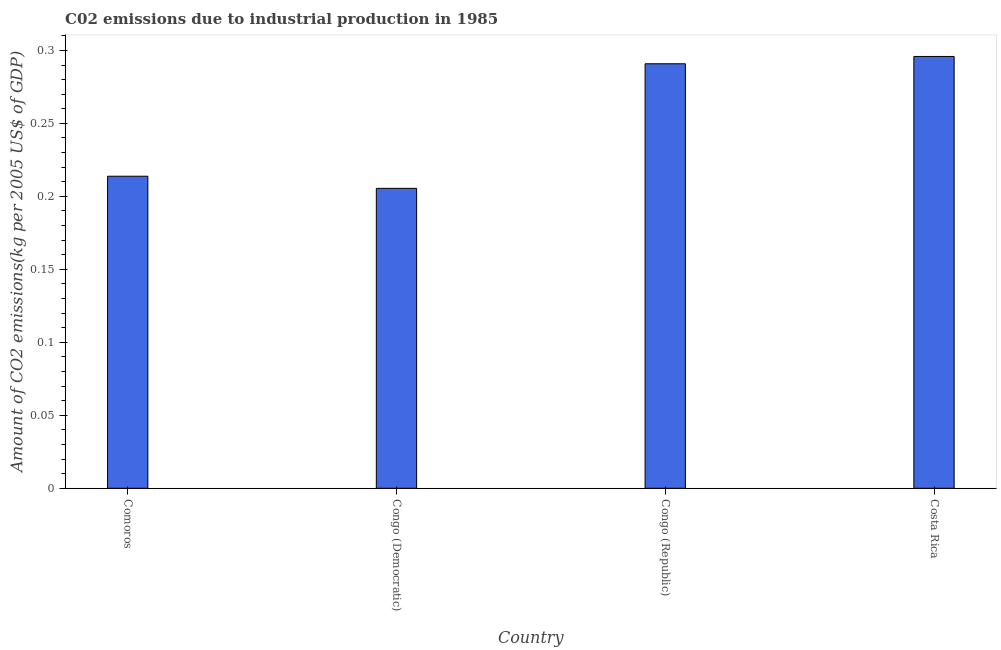Does the graph contain any zero values?
Give a very brief answer. No. What is the title of the graph?
Offer a very short reply. C02 emissions due to industrial production in 1985. What is the label or title of the X-axis?
Your answer should be compact. Country. What is the label or title of the Y-axis?
Give a very brief answer. Amount of CO2 emissions(kg per 2005 US$ of GDP). What is the amount of co2 emissions in Costa Rica?
Offer a terse response. 0.3. Across all countries, what is the maximum amount of co2 emissions?
Ensure brevity in your answer.  0.3. Across all countries, what is the minimum amount of co2 emissions?
Provide a short and direct response. 0.21. In which country was the amount of co2 emissions minimum?
Offer a very short reply. Congo (Democratic). What is the sum of the amount of co2 emissions?
Offer a very short reply. 1.01. What is the difference between the amount of co2 emissions in Comoros and Congo (Democratic)?
Give a very brief answer. 0.01. What is the average amount of co2 emissions per country?
Offer a very short reply. 0.25. What is the median amount of co2 emissions?
Give a very brief answer. 0.25. In how many countries, is the amount of co2 emissions greater than 0.29 kg per 2005 US$ of GDP?
Make the answer very short. 2. What is the ratio of the amount of co2 emissions in Comoros to that in Congo (Republic)?
Provide a succinct answer. 0.73. Is the amount of co2 emissions in Comoros less than that in Congo (Republic)?
Provide a short and direct response. Yes. Is the difference between the amount of co2 emissions in Congo (Democratic) and Congo (Republic) greater than the difference between any two countries?
Provide a short and direct response. No. What is the difference between the highest and the second highest amount of co2 emissions?
Offer a terse response. 0.01. Is the sum of the amount of co2 emissions in Congo (Democratic) and Costa Rica greater than the maximum amount of co2 emissions across all countries?
Offer a very short reply. Yes. What is the difference between the highest and the lowest amount of co2 emissions?
Offer a very short reply. 0.09. In how many countries, is the amount of co2 emissions greater than the average amount of co2 emissions taken over all countries?
Your answer should be compact. 2. How many bars are there?
Give a very brief answer. 4. Are all the bars in the graph horizontal?
Your response must be concise. No. Are the values on the major ticks of Y-axis written in scientific E-notation?
Provide a short and direct response. No. What is the Amount of CO2 emissions(kg per 2005 US$ of GDP) of Comoros?
Provide a short and direct response. 0.21. What is the Amount of CO2 emissions(kg per 2005 US$ of GDP) of Congo (Democratic)?
Provide a short and direct response. 0.21. What is the Amount of CO2 emissions(kg per 2005 US$ of GDP) in Congo (Republic)?
Your answer should be compact. 0.29. What is the Amount of CO2 emissions(kg per 2005 US$ of GDP) of Costa Rica?
Your response must be concise. 0.3. What is the difference between the Amount of CO2 emissions(kg per 2005 US$ of GDP) in Comoros and Congo (Democratic)?
Offer a very short reply. 0.01. What is the difference between the Amount of CO2 emissions(kg per 2005 US$ of GDP) in Comoros and Congo (Republic)?
Provide a short and direct response. -0.08. What is the difference between the Amount of CO2 emissions(kg per 2005 US$ of GDP) in Comoros and Costa Rica?
Make the answer very short. -0.08. What is the difference between the Amount of CO2 emissions(kg per 2005 US$ of GDP) in Congo (Democratic) and Congo (Republic)?
Your response must be concise. -0.09. What is the difference between the Amount of CO2 emissions(kg per 2005 US$ of GDP) in Congo (Democratic) and Costa Rica?
Keep it short and to the point. -0.09. What is the difference between the Amount of CO2 emissions(kg per 2005 US$ of GDP) in Congo (Republic) and Costa Rica?
Offer a very short reply. -0.01. What is the ratio of the Amount of CO2 emissions(kg per 2005 US$ of GDP) in Comoros to that in Congo (Democratic)?
Your answer should be very brief. 1.04. What is the ratio of the Amount of CO2 emissions(kg per 2005 US$ of GDP) in Comoros to that in Congo (Republic)?
Your answer should be very brief. 0.73. What is the ratio of the Amount of CO2 emissions(kg per 2005 US$ of GDP) in Comoros to that in Costa Rica?
Provide a short and direct response. 0.72. What is the ratio of the Amount of CO2 emissions(kg per 2005 US$ of GDP) in Congo (Democratic) to that in Congo (Republic)?
Provide a short and direct response. 0.71. What is the ratio of the Amount of CO2 emissions(kg per 2005 US$ of GDP) in Congo (Democratic) to that in Costa Rica?
Provide a short and direct response. 0.69. 